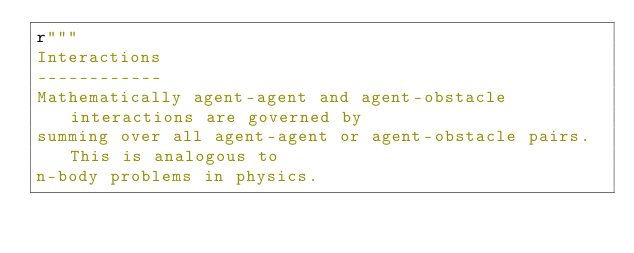Convert code to text. <code><loc_0><loc_0><loc_500><loc_500><_Python_>r"""
Interactions
------------
Mathematically agent-agent and agent-obstacle interactions are governed by
summing over all agent-agent or agent-obstacle pairs. This is analogous to
n-body problems in physics.
</code> 